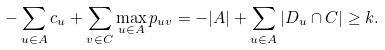<formula> <loc_0><loc_0><loc_500><loc_500>- \sum _ { u \in A } c _ { u } + \sum _ { v \in C } \max _ { u \in A } p _ { u v } = - | A | + \sum _ { u \in A } | D _ { u } \cap C | \geq k .</formula> 